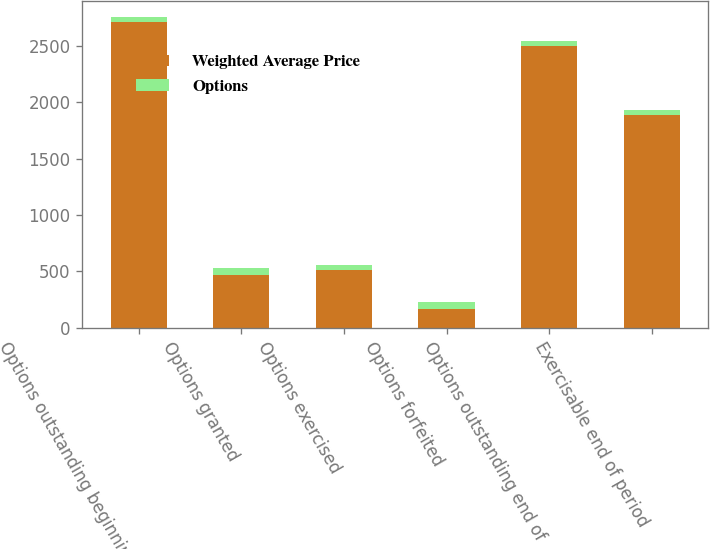<chart> <loc_0><loc_0><loc_500><loc_500><stacked_bar_chart><ecel><fcel>Options outstanding beginning<fcel>Options granted<fcel>Options exercised<fcel>Options forfeited<fcel>Options outstanding end of<fcel>Exercisable end of period<nl><fcel>Weighted Average Price<fcel>2717<fcel>468<fcel>517<fcel>165<fcel>2503<fcel>1888<nl><fcel>Options<fcel>43<fcel>63<fcel>39<fcel>64<fcel>47<fcel>42<nl></chart> 